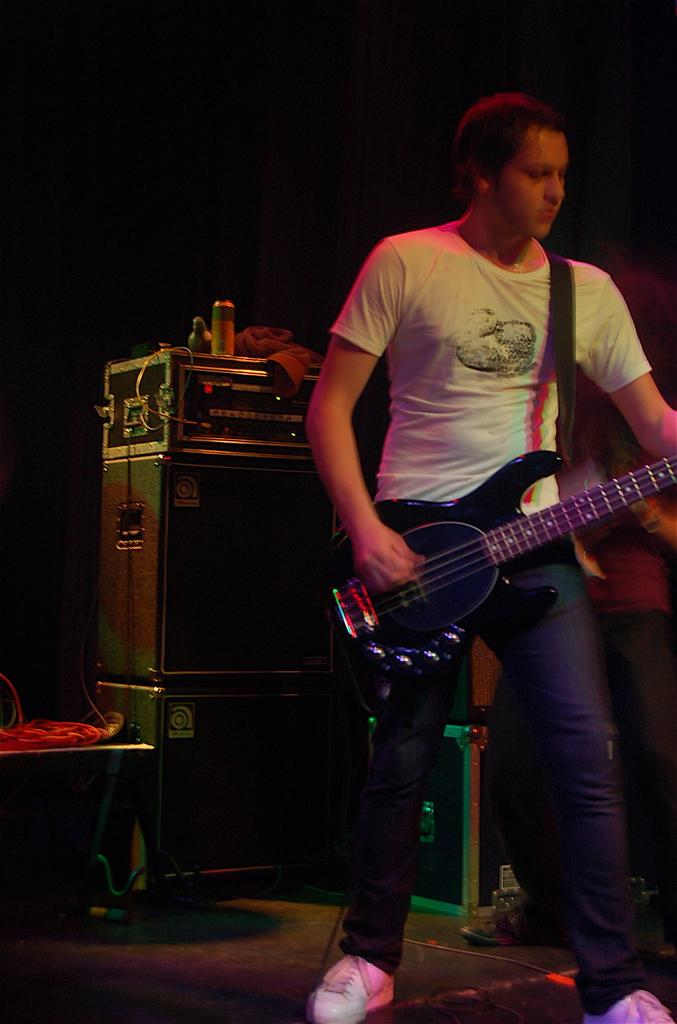What is the man in the image doing? The man is playing a guitar. What is the man's position in relation to the ground? The man is standing on the ground. Can you describe the object behind the man? Unfortunately, the provided facts do not give enough information to describe the object behind the man. How does the man transport the guitar in the image? The provided facts do not give enough information about how the man is transporting the guitar, if at all. What type of ball is visible in the image? There is no ball present in the image. 